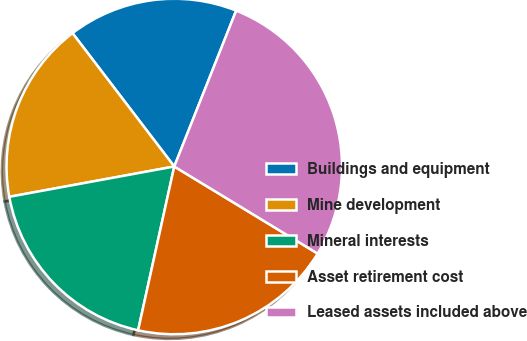Convert chart. <chart><loc_0><loc_0><loc_500><loc_500><pie_chart><fcel>Buildings and equipment<fcel>Mine development<fcel>Mineral interests<fcel>Asset retirement cost<fcel>Leased assets included above<nl><fcel>16.39%<fcel>17.52%<fcel>18.65%<fcel>19.77%<fcel>27.67%<nl></chart> 